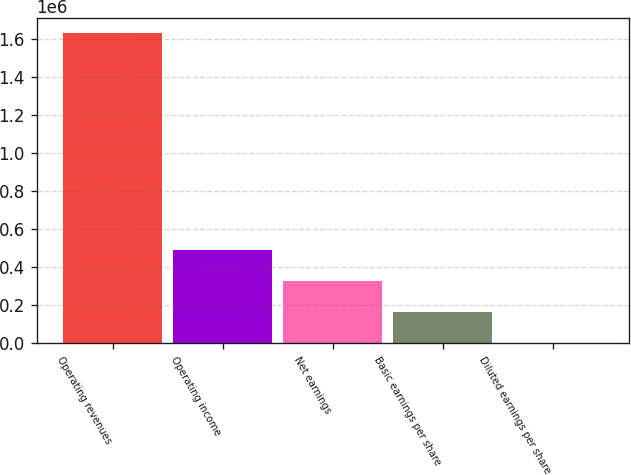Convert chart to OTSL. <chart><loc_0><loc_0><loc_500><loc_500><bar_chart><fcel>Operating revenues<fcel>Operating income<fcel>Net earnings<fcel>Basic earnings per share<fcel>Diluted earnings per share<nl><fcel>1.62916e+06<fcel>488748<fcel>325832<fcel>162917<fcel>0.92<nl></chart> 